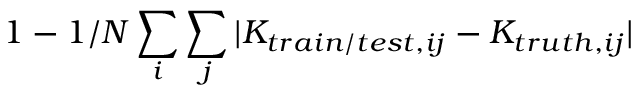<formula> <loc_0><loc_0><loc_500><loc_500>1 - 1 / N \sum _ { i } \sum _ { j } | K _ { t r a i n / t e s t , i j } - K _ { t r u t h , i j } |</formula> 